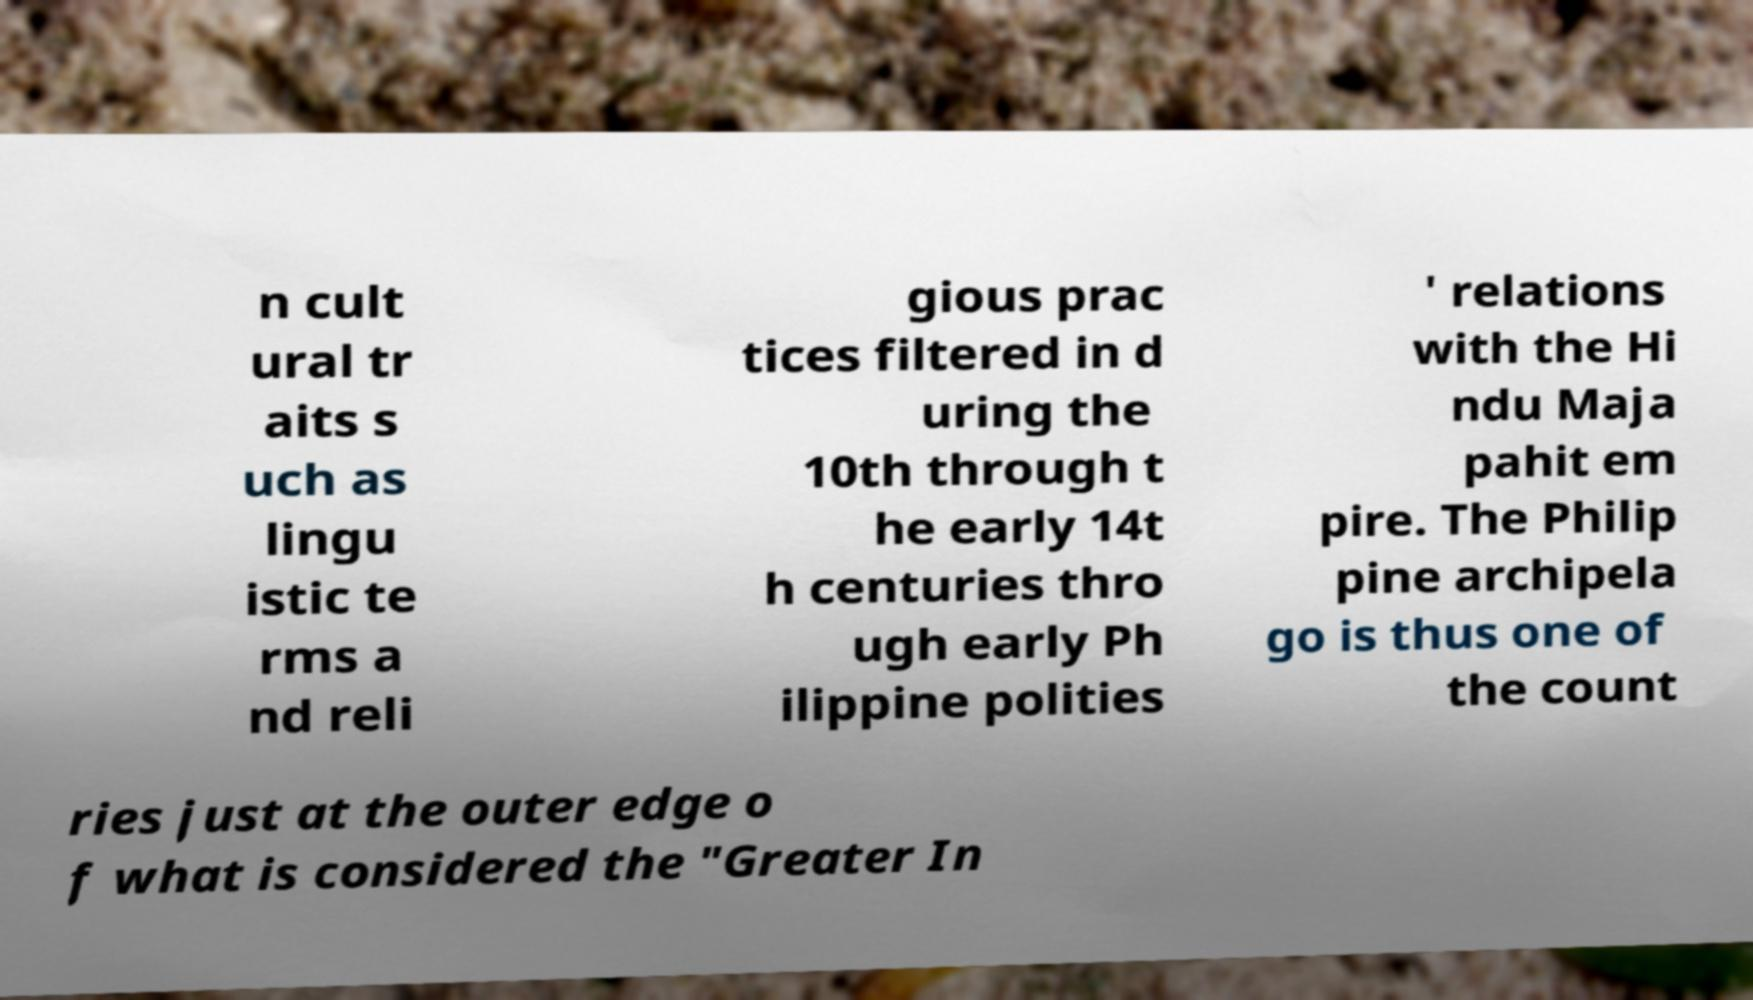There's text embedded in this image that I need extracted. Can you transcribe it verbatim? n cult ural tr aits s uch as lingu istic te rms a nd reli gious prac tices filtered in d uring the 10th through t he early 14t h centuries thro ugh early Ph ilippine polities ' relations with the Hi ndu Maja pahit em pire. The Philip pine archipela go is thus one of the count ries just at the outer edge o f what is considered the "Greater In 